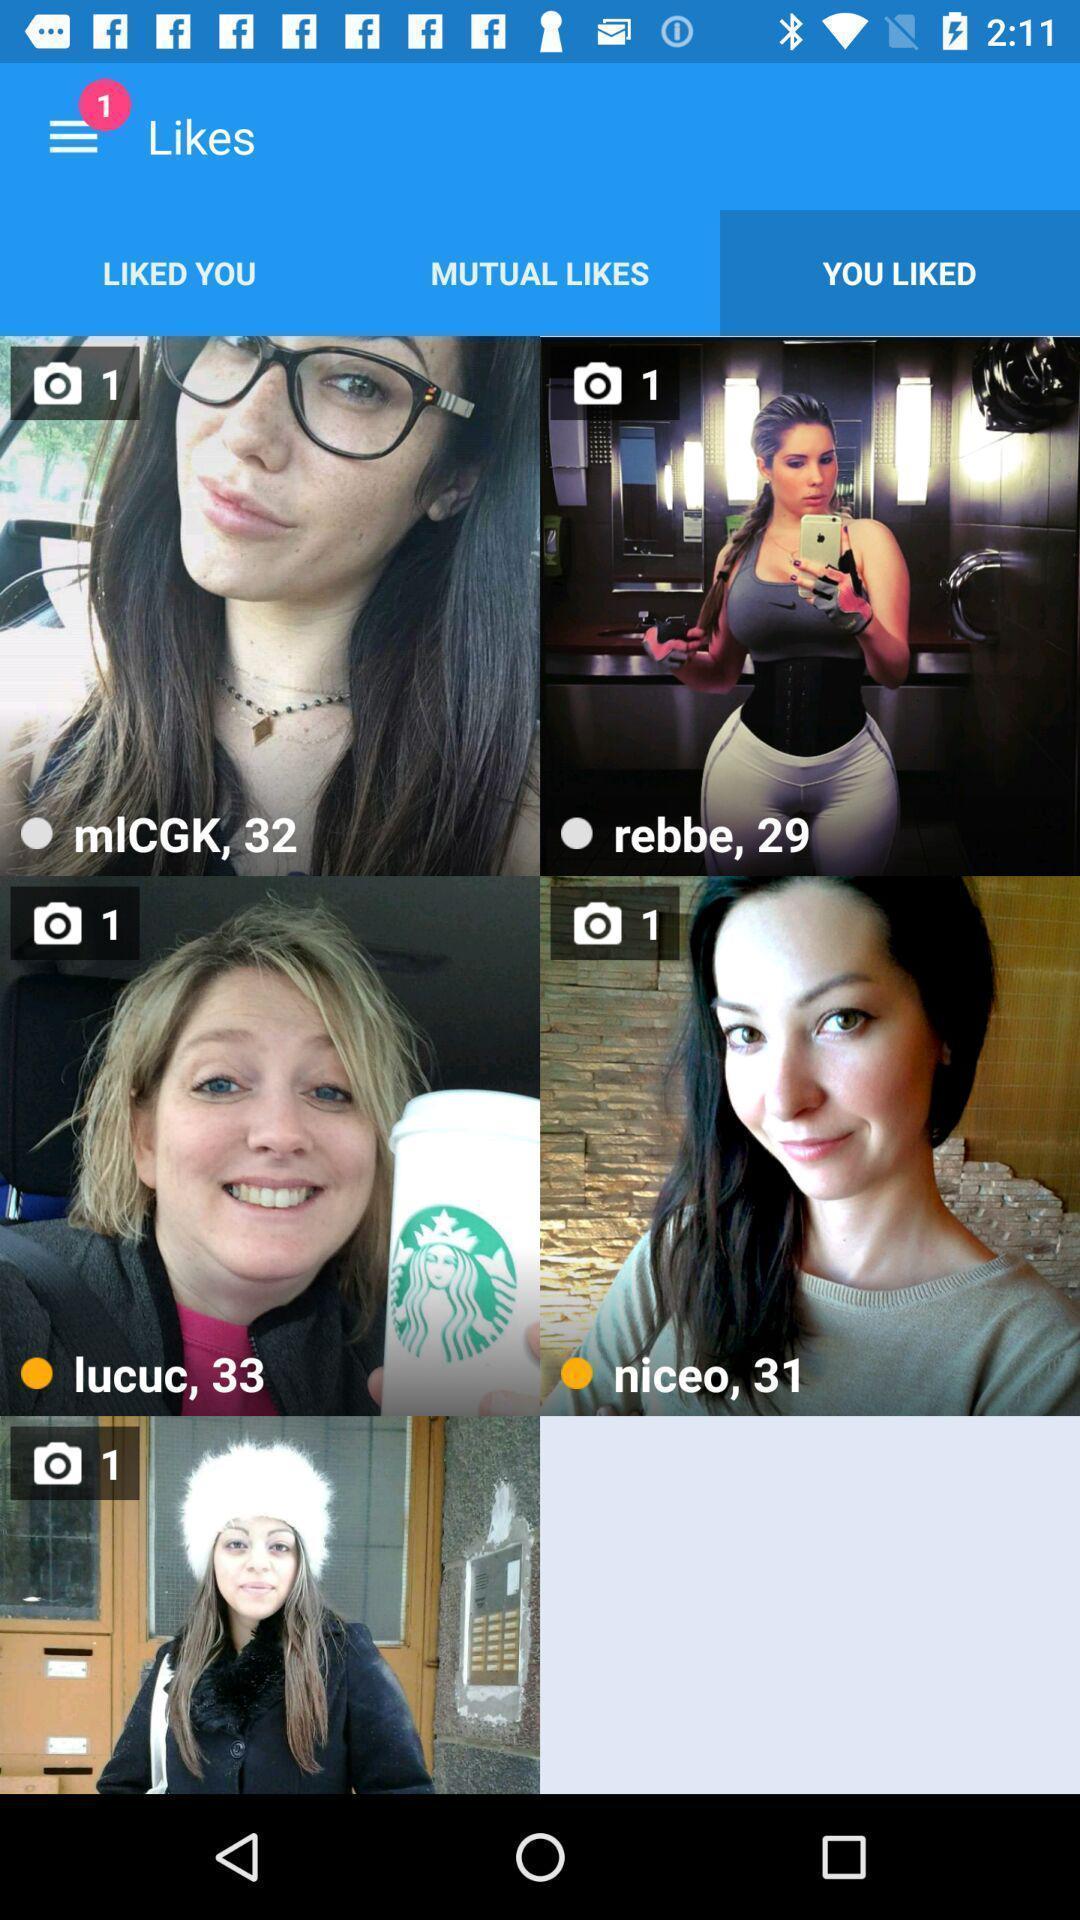Tell me about the visual elements in this screen capture. Screen displaying the liked images. 